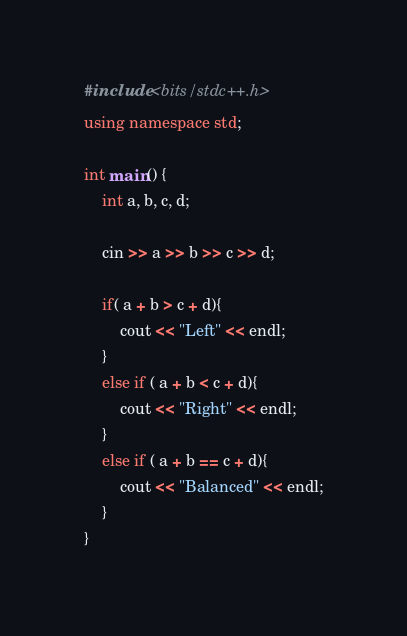<code> <loc_0><loc_0><loc_500><loc_500><_C++_>#include <bits/stdc++.h>
using namespace std;

int main() {
    int a, b, c, d;

    cin >> a >> b >> c >> d;

    if( a + b > c + d){
        cout << "Left" << endl;
    }
    else if ( a + b < c + d){
        cout << "Right" << endl;
    }
    else if ( a + b == c + d){
        cout << "Balanced" << endl;
    }
}</code> 